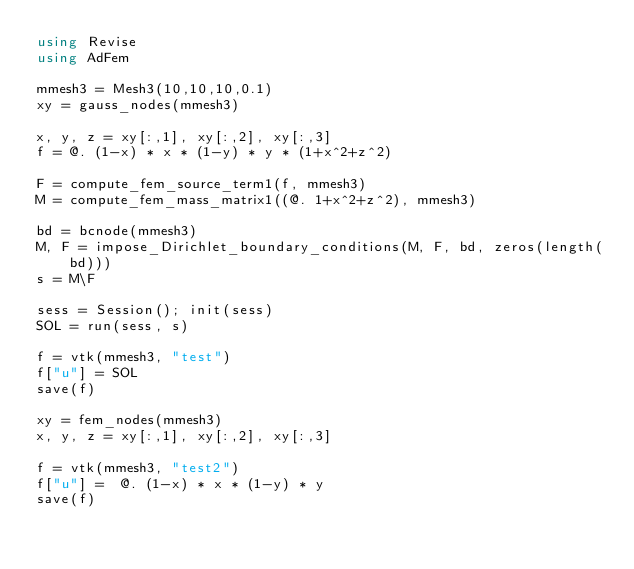Convert code to text. <code><loc_0><loc_0><loc_500><loc_500><_Julia_>using Revise
using AdFem

mmesh3 = Mesh3(10,10,10,0.1)
xy = gauss_nodes(mmesh3)

x, y, z = xy[:,1], xy[:,2], xy[:,3]
f = @. (1-x) * x * (1-y) * y * (1+x^2+z^2)

F = compute_fem_source_term1(f, mmesh3)
M = compute_fem_mass_matrix1((@. 1+x^2+z^2), mmesh3)

bd = bcnode(mmesh3)
M, F = impose_Dirichlet_boundary_conditions(M, F, bd, zeros(length(bd)))
s = M\F

sess = Session(); init(sess)
SOL = run(sess, s)

f = vtk(mmesh3, "test")
f["u"] = SOL 
save(f)

xy = fem_nodes(mmesh3)
x, y, z = xy[:,1], xy[:,2], xy[:,3]

f = vtk(mmesh3, "test2")
f["u"] =  @. (1-x) * x * (1-y) * y
save(f)</code> 